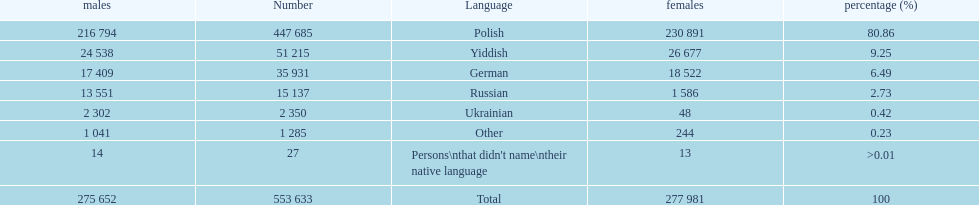Would you be able to parse every entry in this table? {'header': ['males', 'Number', 'Language', 'females', 'percentage (%)'], 'rows': [['216 794', '447 685', 'Polish', '230 891', '80.86'], ['24 538', '51 215', 'Yiddish', '26 677', '9.25'], ['17 409', '35 931', 'German', '18 522', '6.49'], ['13 551', '15 137', 'Russian', '1 586', '2.73'], ['2 302', '2 350', 'Ukrainian', '48', '0.42'], ['1 041', '1 285', 'Other', '244', '0.23'], ['14', '27', "Persons\\nthat didn't name\\ntheir native language", '13', '>0.01'], ['275 652', '553 633', 'Total', '277 981', '100']]} How many male and female german speakers are there? 35931. 